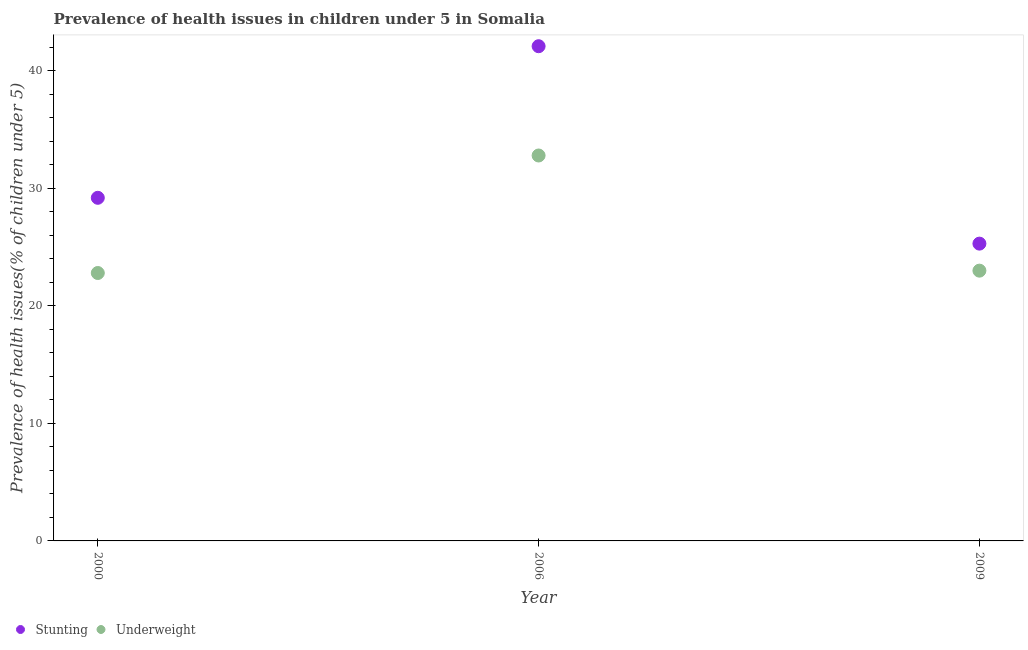Is the number of dotlines equal to the number of legend labels?
Offer a terse response. Yes. What is the percentage of stunted children in 2000?
Ensure brevity in your answer.  29.2. Across all years, what is the maximum percentage of underweight children?
Ensure brevity in your answer.  32.8. Across all years, what is the minimum percentage of stunted children?
Make the answer very short. 25.3. In which year was the percentage of underweight children minimum?
Your response must be concise. 2000. What is the total percentage of stunted children in the graph?
Offer a terse response. 96.6. What is the difference between the percentage of stunted children in 2000 and that in 2006?
Give a very brief answer. -12.9. What is the difference between the percentage of stunted children in 2006 and the percentage of underweight children in 2000?
Your response must be concise. 19.3. What is the average percentage of underweight children per year?
Offer a very short reply. 26.2. In the year 2009, what is the difference between the percentage of underweight children and percentage of stunted children?
Offer a very short reply. -2.3. What is the ratio of the percentage of underweight children in 2000 to that in 2006?
Ensure brevity in your answer.  0.7. What is the difference between the highest and the second highest percentage of underweight children?
Make the answer very short. 9.8. What is the difference between the highest and the lowest percentage of stunted children?
Give a very brief answer. 16.8. Is the sum of the percentage of stunted children in 2006 and 2009 greater than the maximum percentage of underweight children across all years?
Provide a succinct answer. Yes. Does the percentage of stunted children monotonically increase over the years?
Keep it short and to the point. No. Is the percentage of underweight children strictly greater than the percentage of stunted children over the years?
Offer a terse response. No. How many dotlines are there?
Provide a succinct answer. 2. How many years are there in the graph?
Your answer should be compact. 3. Does the graph contain grids?
Ensure brevity in your answer.  No. Where does the legend appear in the graph?
Keep it short and to the point. Bottom left. How many legend labels are there?
Your answer should be compact. 2. How are the legend labels stacked?
Your answer should be compact. Horizontal. What is the title of the graph?
Provide a succinct answer. Prevalence of health issues in children under 5 in Somalia. What is the label or title of the Y-axis?
Ensure brevity in your answer.  Prevalence of health issues(% of children under 5). What is the Prevalence of health issues(% of children under 5) in Stunting in 2000?
Your answer should be compact. 29.2. What is the Prevalence of health issues(% of children under 5) in Underweight in 2000?
Make the answer very short. 22.8. What is the Prevalence of health issues(% of children under 5) in Stunting in 2006?
Give a very brief answer. 42.1. What is the Prevalence of health issues(% of children under 5) of Underweight in 2006?
Your answer should be very brief. 32.8. What is the Prevalence of health issues(% of children under 5) in Stunting in 2009?
Give a very brief answer. 25.3. Across all years, what is the maximum Prevalence of health issues(% of children under 5) in Stunting?
Provide a succinct answer. 42.1. Across all years, what is the maximum Prevalence of health issues(% of children under 5) of Underweight?
Your response must be concise. 32.8. Across all years, what is the minimum Prevalence of health issues(% of children under 5) in Stunting?
Provide a short and direct response. 25.3. Across all years, what is the minimum Prevalence of health issues(% of children under 5) in Underweight?
Keep it short and to the point. 22.8. What is the total Prevalence of health issues(% of children under 5) of Stunting in the graph?
Your answer should be very brief. 96.6. What is the total Prevalence of health issues(% of children under 5) in Underweight in the graph?
Keep it short and to the point. 78.6. What is the difference between the Prevalence of health issues(% of children under 5) of Stunting in 2000 and that in 2006?
Keep it short and to the point. -12.9. What is the difference between the Prevalence of health issues(% of children under 5) of Stunting in 2000 and the Prevalence of health issues(% of children under 5) of Underweight in 2006?
Provide a short and direct response. -3.6. What is the difference between the Prevalence of health issues(% of children under 5) of Stunting in 2000 and the Prevalence of health issues(% of children under 5) of Underweight in 2009?
Your answer should be compact. 6.2. What is the average Prevalence of health issues(% of children under 5) in Stunting per year?
Provide a short and direct response. 32.2. What is the average Prevalence of health issues(% of children under 5) in Underweight per year?
Ensure brevity in your answer.  26.2. In the year 2000, what is the difference between the Prevalence of health issues(% of children under 5) of Stunting and Prevalence of health issues(% of children under 5) of Underweight?
Give a very brief answer. 6.4. In the year 2006, what is the difference between the Prevalence of health issues(% of children under 5) in Stunting and Prevalence of health issues(% of children under 5) in Underweight?
Your answer should be compact. 9.3. In the year 2009, what is the difference between the Prevalence of health issues(% of children under 5) in Stunting and Prevalence of health issues(% of children under 5) in Underweight?
Give a very brief answer. 2.3. What is the ratio of the Prevalence of health issues(% of children under 5) in Stunting in 2000 to that in 2006?
Your response must be concise. 0.69. What is the ratio of the Prevalence of health issues(% of children under 5) of Underweight in 2000 to that in 2006?
Offer a very short reply. 0.7. What is the ratio of the Prevalence of health issues(% of children under 5) of Stunting in 2000 to that in 2009?
Offer a terse response. 1.15. What is the ratio of the Prevalence of health issues(% of children under 5) in Underweight in 2000 to that in 2009?
Offer a terse response. 0.99. What is the ratio of the Prevalence of health issues(% of children under 5) in Stunting in 2006 to that in 2009?
Provide a succinct answer. 1.66. What is the ratio of the Prevalence of health issues(% of children under 5) of Underweight in 2006 to that in 2009?
Provide a short and direct response. 1.43. What is the difference between the highest and the second highest Prevalence of health issues(% of children under 5) of Stunting?
Your answer should be compact. 12.9. 